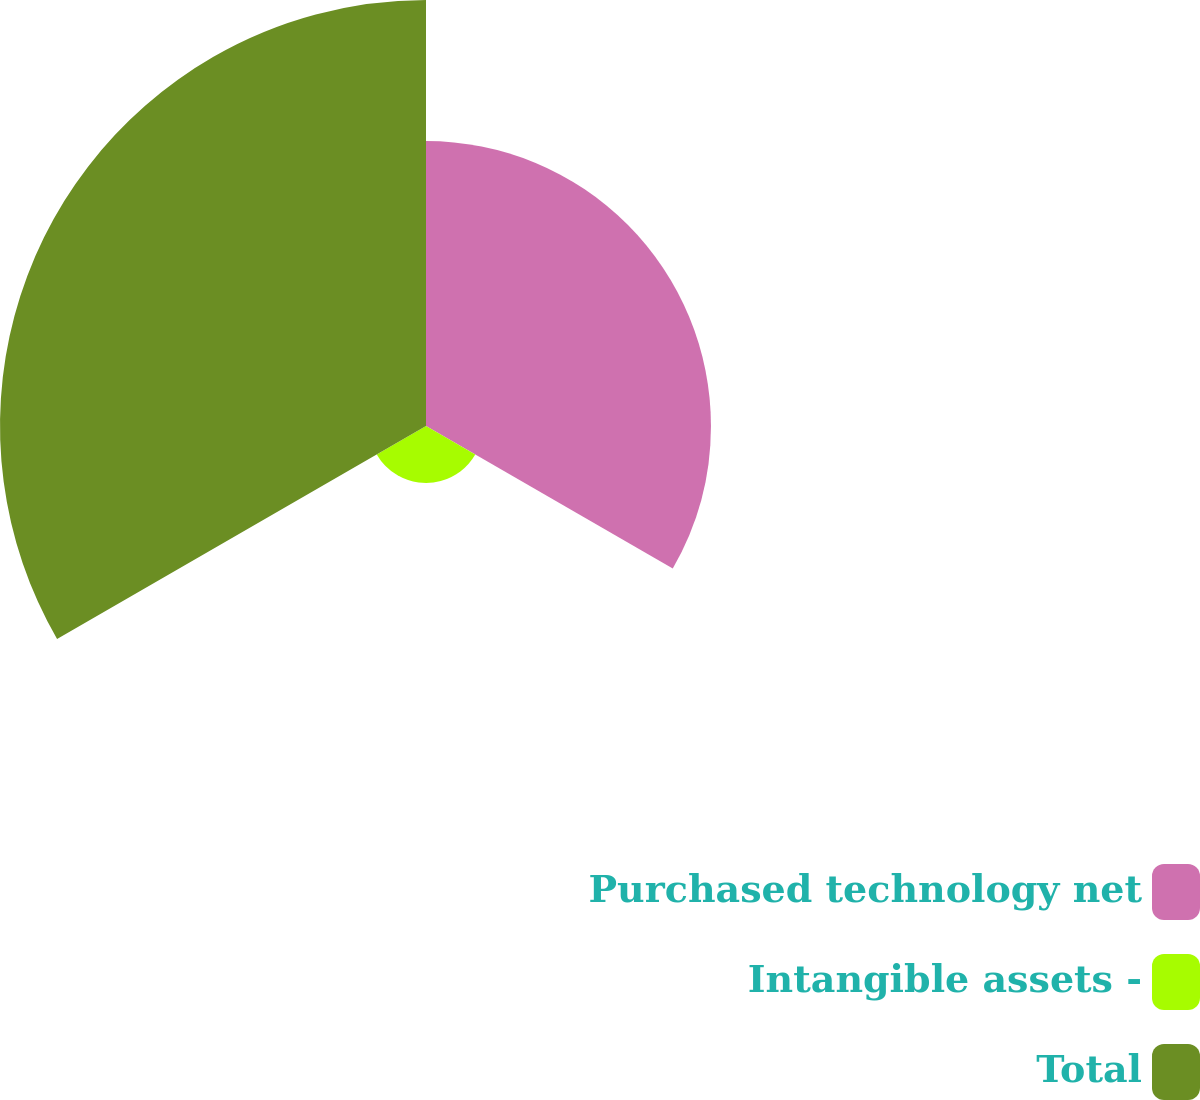<chart> <loc_0><loc_0><loc_500><loc_500><pie_chart><fcel>Purchased technology net<fcel>Intangible assets -<fcel>Total<nl><fcel>37.11%<fcel>7.41%<fcel>55.48%<nl></chart> 